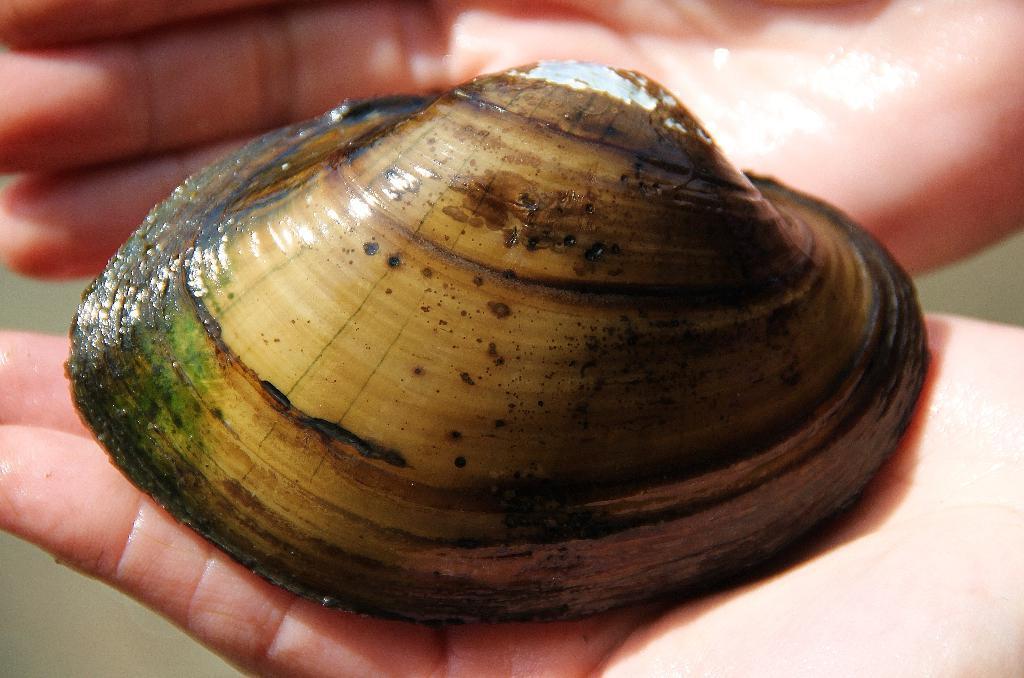Can you describe this image briefly? In this picture we can observe a shell which is in brown and cream color in the hands of a human. The background is completely blurred. 